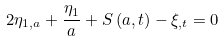Convert formula to latex. <formula><loc_0><loc_0><loc_500><loc_500>2 \eta _ { 1 , a } + \frac { \eta _ { 1 } } { a } + S \left ( a , t \right ) - \xi _ { , t } = 0</formula> 